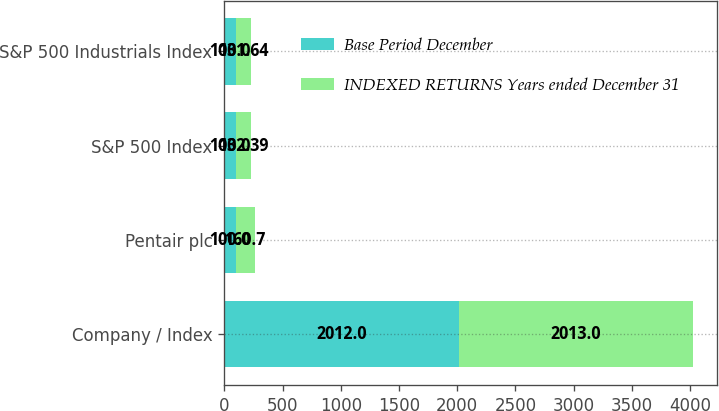Convert chart. <chart><loc_0><loc_0><loc_500><loc_500><stacked_bar_chart><ecel><fcel>Company / Index<fcel>Pentair plc<fcel>S&P 500 Index<fcel>S&P 500 Industrials Index<nl><fcel>Base Period December<fcel>2012<fcel>100<fcel>100<fcel>100<nl><fcel>INDEXED RETURNS Years ended December 31<fcel>2013<fcel>160.7<fcel>132.39<fcel>131.64<nl></chart> 